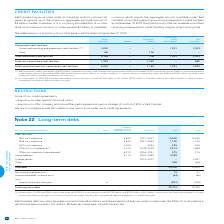According to Bce's financial document, What is Bell Canada's outstanding commercial paper in 2019? $1,502 million in U.S. dollars ($1,951 million in Canadian dollars). The document states: "ell Canada’s outstanding commercial paper included $1,502 million in U.S. dollars ($1,951 million in Canadian dollars). All of Bell Canada’s commercia..." Also, What is the net available amount for the total committed and non-committed credit facilities? According to the financial document, 2,929. The relevant text states: "n-committed credit facilities 6,045 – 1,165 1,951 2,929..." Also, When do the revolving credit facilities expire? The document shows two values: November 2024 and November 2020. From the document: "ing credit facilities expire in November 2024 and November 2020, respectively, and its $1 billion committed expansion credit facility expires in Novem..." Also, How many segments of committed credit facilities are there? Counting the relevant items in the document: Unsecured revolving and expansion credit facilities, Other, I find 2 instances. The key data points involved are: Other, Unsecured revolving and expansion credit facilities. Also, can you calculate: What is the ratio of the net available total committed credit facilities over the net available total non-committed credit facilities? Based on the calculation: 2,049/880, the result is 2.33. This is based on the information: "pansion credit facilities (1) (2) 4,000 – – 1,951 2,049 l non-committed credit facilities 1,939 – 1,059 – 880..." The key data points involved are: 2,049, 880. Also, can you calculate: What percentage of the total non-committed credit facilities available is classified as net available?  Based on the calculation: 880/1,939, the result is 45.38 (percentage). This is based on the information: "Total non-committed credit facilities 1,939 – 1,059 – 880 l non-committed credit facilities 1,939 – 1,059 – 880..." The key data points involved are: 1,939, 880. 